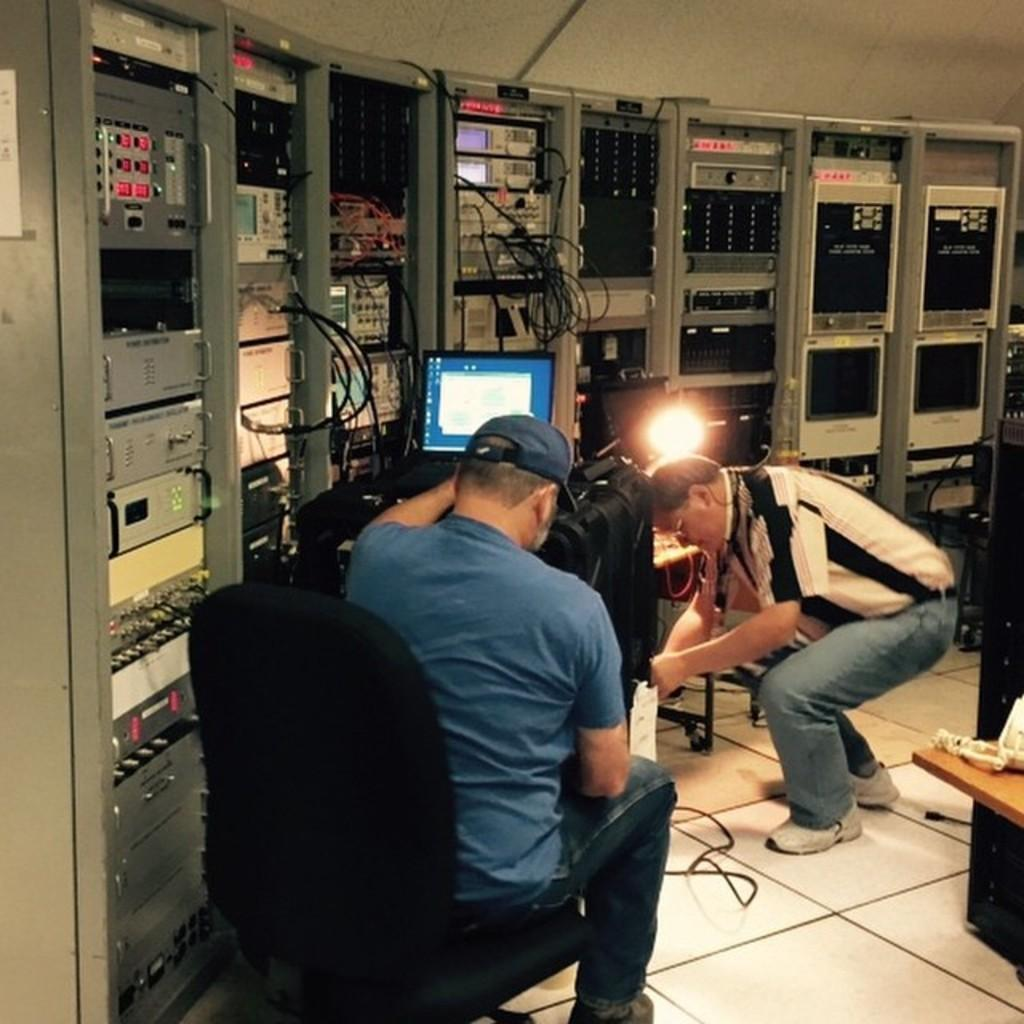What type of room is shown in the image? The image depicts a generator room. How many people are present in the image? There are two people in the image. What are the two people doing in the image? The two people are working on a laptop. How many lizards can be seen crawling on the generator in the image? There are no lizards present in the image; it only shows a generator room with two people working on a laptop. 